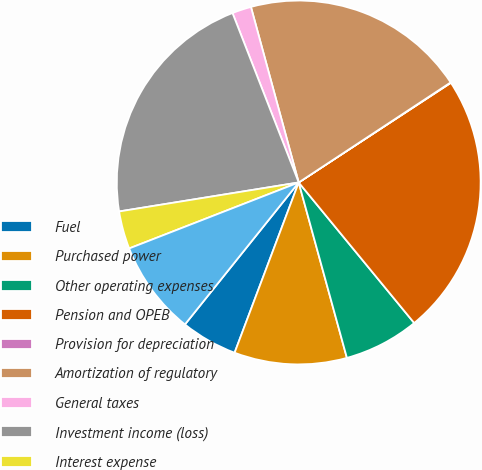Convert chart to OTSL. <chart><loc_0><loc_0><loc_500><loc_500><pie_chart><fcel>Fuel<fcel>Purchased power<fcel>Other operating expenses<fcel>Pension and OPEB<fcel>Provision for depreciation<fcel>Amortization of regulatory<fcel>General taxes<fcel>Investment income (loss)<fcel>Interest expense<fcel>Total other expense<nl><fcel>5.02%<fcel>10.0%<fcel>6.68%<fcel>23.28%<fcel>0.04%<fcel>19.96%<fcel>1.7%<fcel>21.62%<fcel>3.36%<fcel>8.34%<nl></chart> 